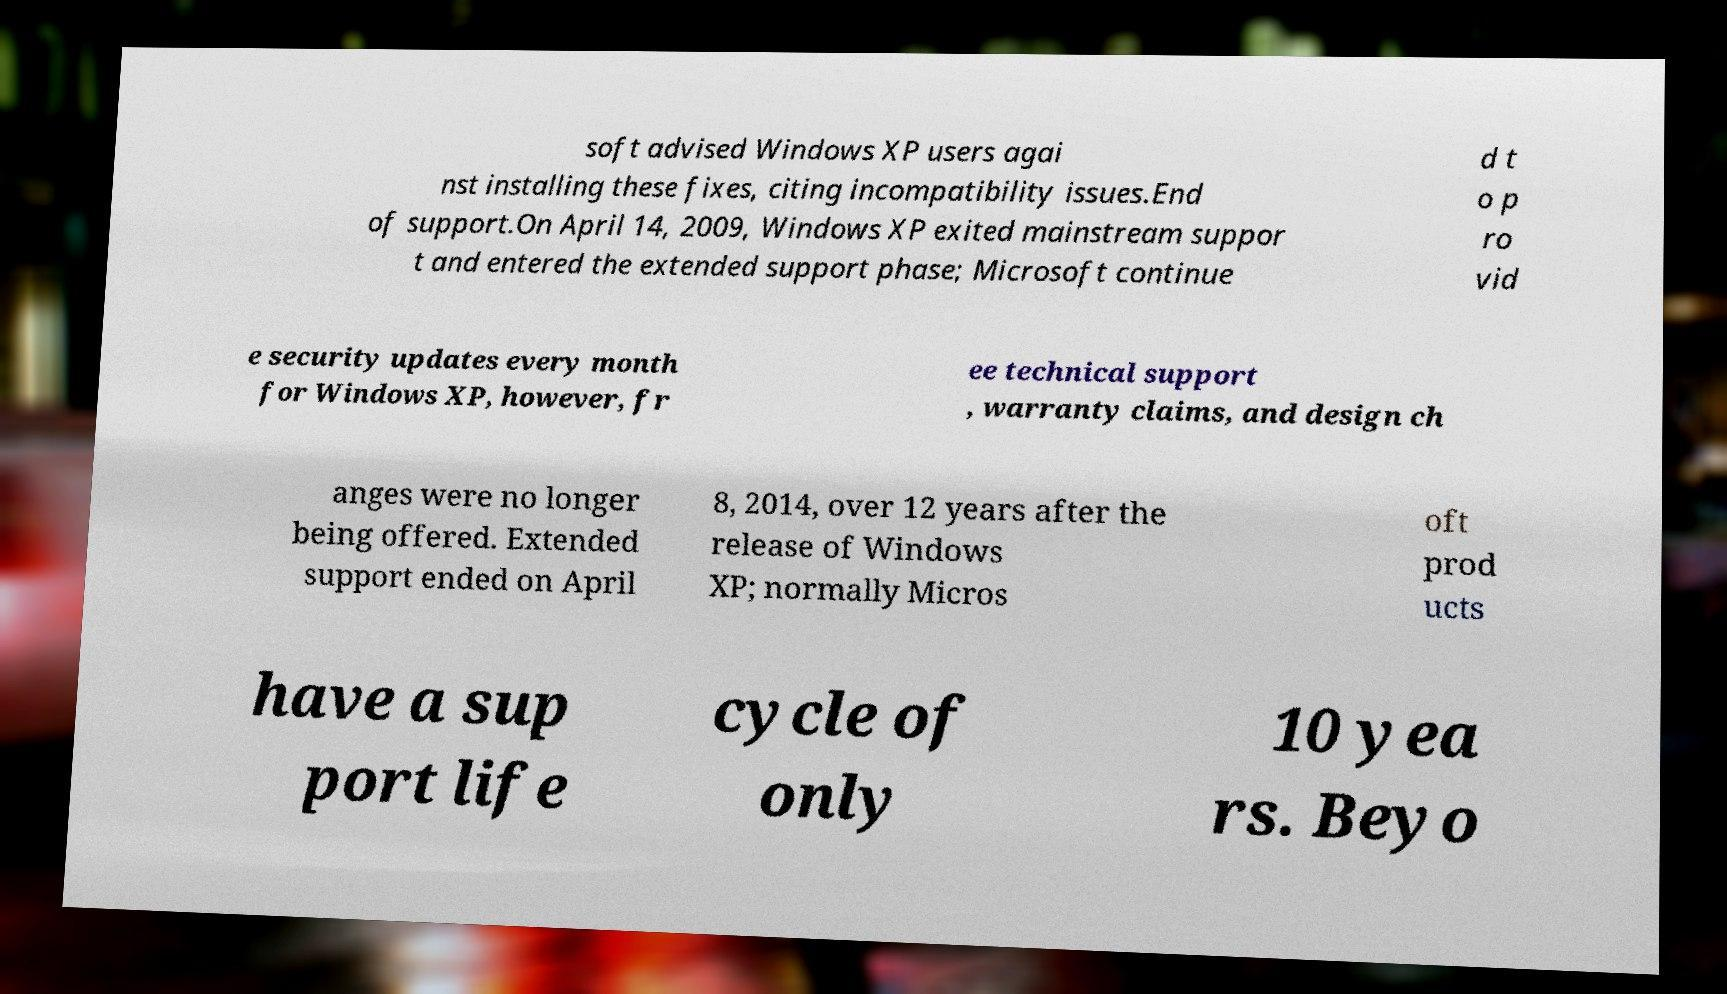Please read and relay the text visible in this image. What does it say? soft advised Windows XP users agai nst installing these fixes, citing incompatibility issues.End of support.On April 14, 2009, Windows XP exited mainstream suppor t and entered the extended support phase; Microsoft continue d t o p ro vid e security updates every month for Windows XP, however, fr ee technical support , warranty claims, and design ch anges were no longer being offered. Extended support ended on April 8, 2014, over 12 years after the release of Windows XP; normally Micros oft prod ucts have a sup port life cycle of only 10 yea rs. Beyo 